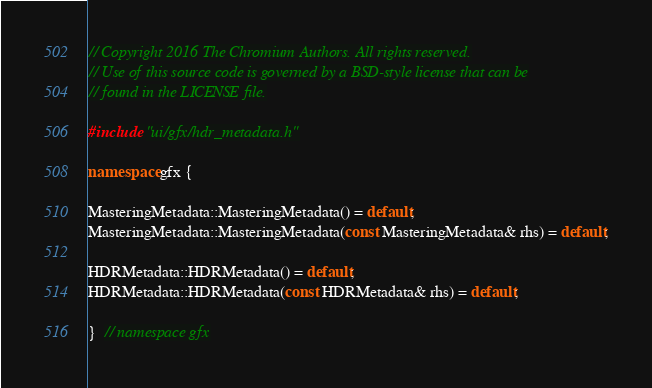Convert code to text. <code><loc_0><loc_0><loc_500><loc_500><_C++_>// Copyright 2016 The Chromium Authors. All rights reserved.
// Use of this source code is governed by a BSD-style license that can be
// found in the LICENSE file.

#include "ui/gfx/hdr_metadata.h"

namespace gfx {

MasteringMetadata::MasteringMetadata() = default;
MasteringMetadata::MasteringMetadata(const MasteringMetadata& rhs) = default;

HDRMetadata::HDRMetadata() = default;
HDRMetadata::HDRMetadata(const HDRMetadata& rhs) = default;

}  // namespace gfx
</code> 